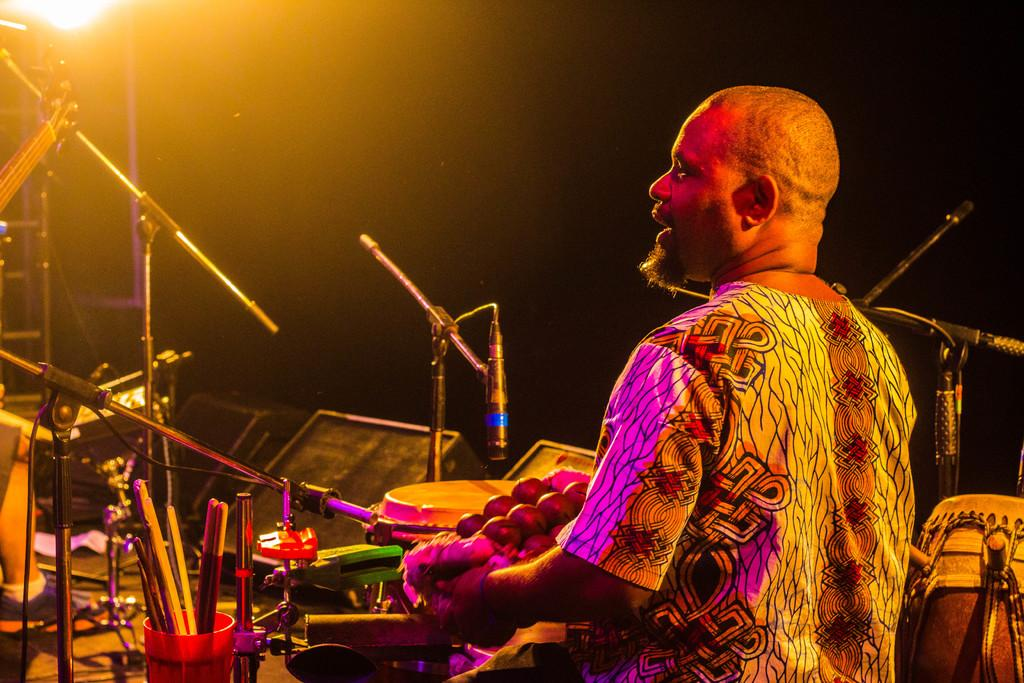What is the main subject of the image? There is a man standing in the image. What is located in front of the man? There is a box and some stands in front of the man. What else can be seen in front of the man? Some musical instruments are placed in front of the man. Can you describe the drum in the image? There is a drum on the right side of the image. What is the purpose of the floor in the image? The image does not show the floor, so it is not possible to determine its purpose. 